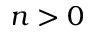Convert formula to latex. <formula><loc_0><loc_0><loc_500><loc_500>n > 0</formula> 